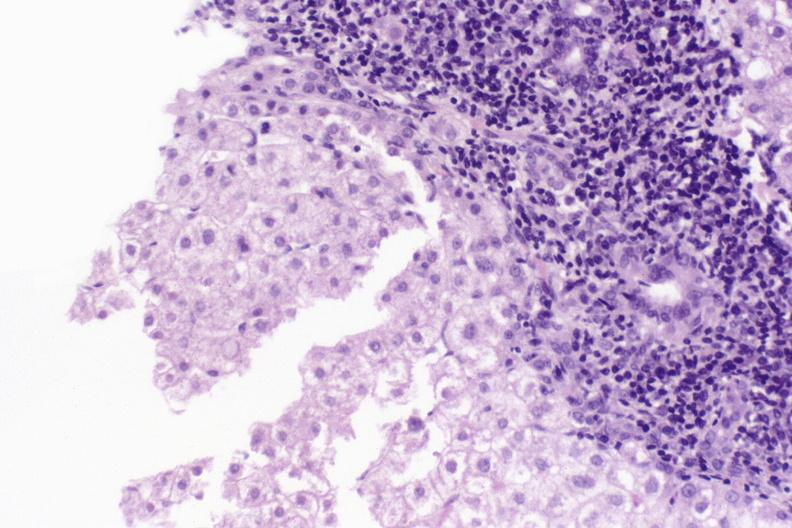s hepatobiliary present?
Answer the question using a single word or phrase. Yes 